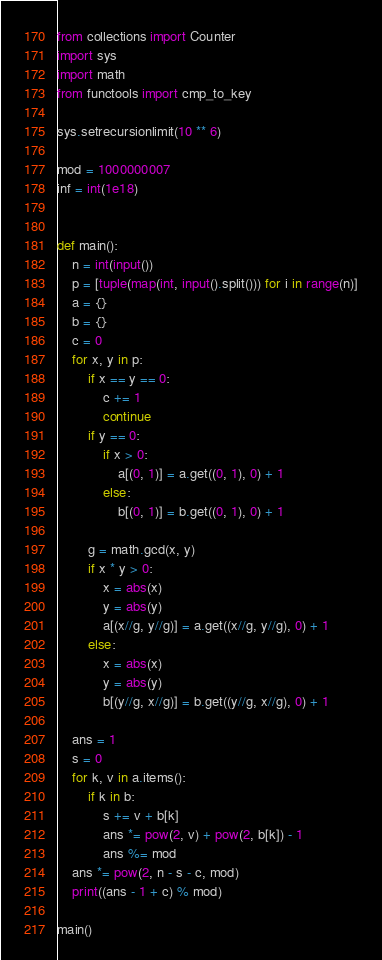Convert code to text. <code><loc_0><loc_0><loc_500><loc_500><_Python_>from collections import Counter
import sys
import math
from functools import cmp_to_key

sys.setrecursionlimit(10 ** 6)

mod = 1000000007
inf = int(1e18)


def main():
    n = int(input())
    p = [tuple(map(int, input().split())) for i in range(n)]
    a = {}
    b = {}
    c = 0
    for x, y in p:
        if x == y == 0:
            c += 1
            continue
        if y == 0:
            if x > 0:
                a[(0, 1)] = a.get((0, 1), 0) + 1
            else:
                b[(0, 1)] = b.get((0, 1), 0) + 1

        g = math.gcd(x, y)
        if x * y > 0:
            x = abs(x)
            y = abs(y)
            a[(x//g, y//g)] = a.get((x//g, y//g), 0) + 1
        else:
            x = abs(x)
            y = abs(y)
            b[(y//g, x//g)] = b.get((y//g, x//g), 0) + 1

    ans = 1
    s = 0
    for k, v in a.items():
        if k in b:
            s += v + b[k]
            ans *= pow(2, v) + pow(2, b[k]) - 1
            ans %= mod
    ans *= pow(2, n - s - c, mod)
    print((ans - 1 + c) % mod)

main()
</code> 